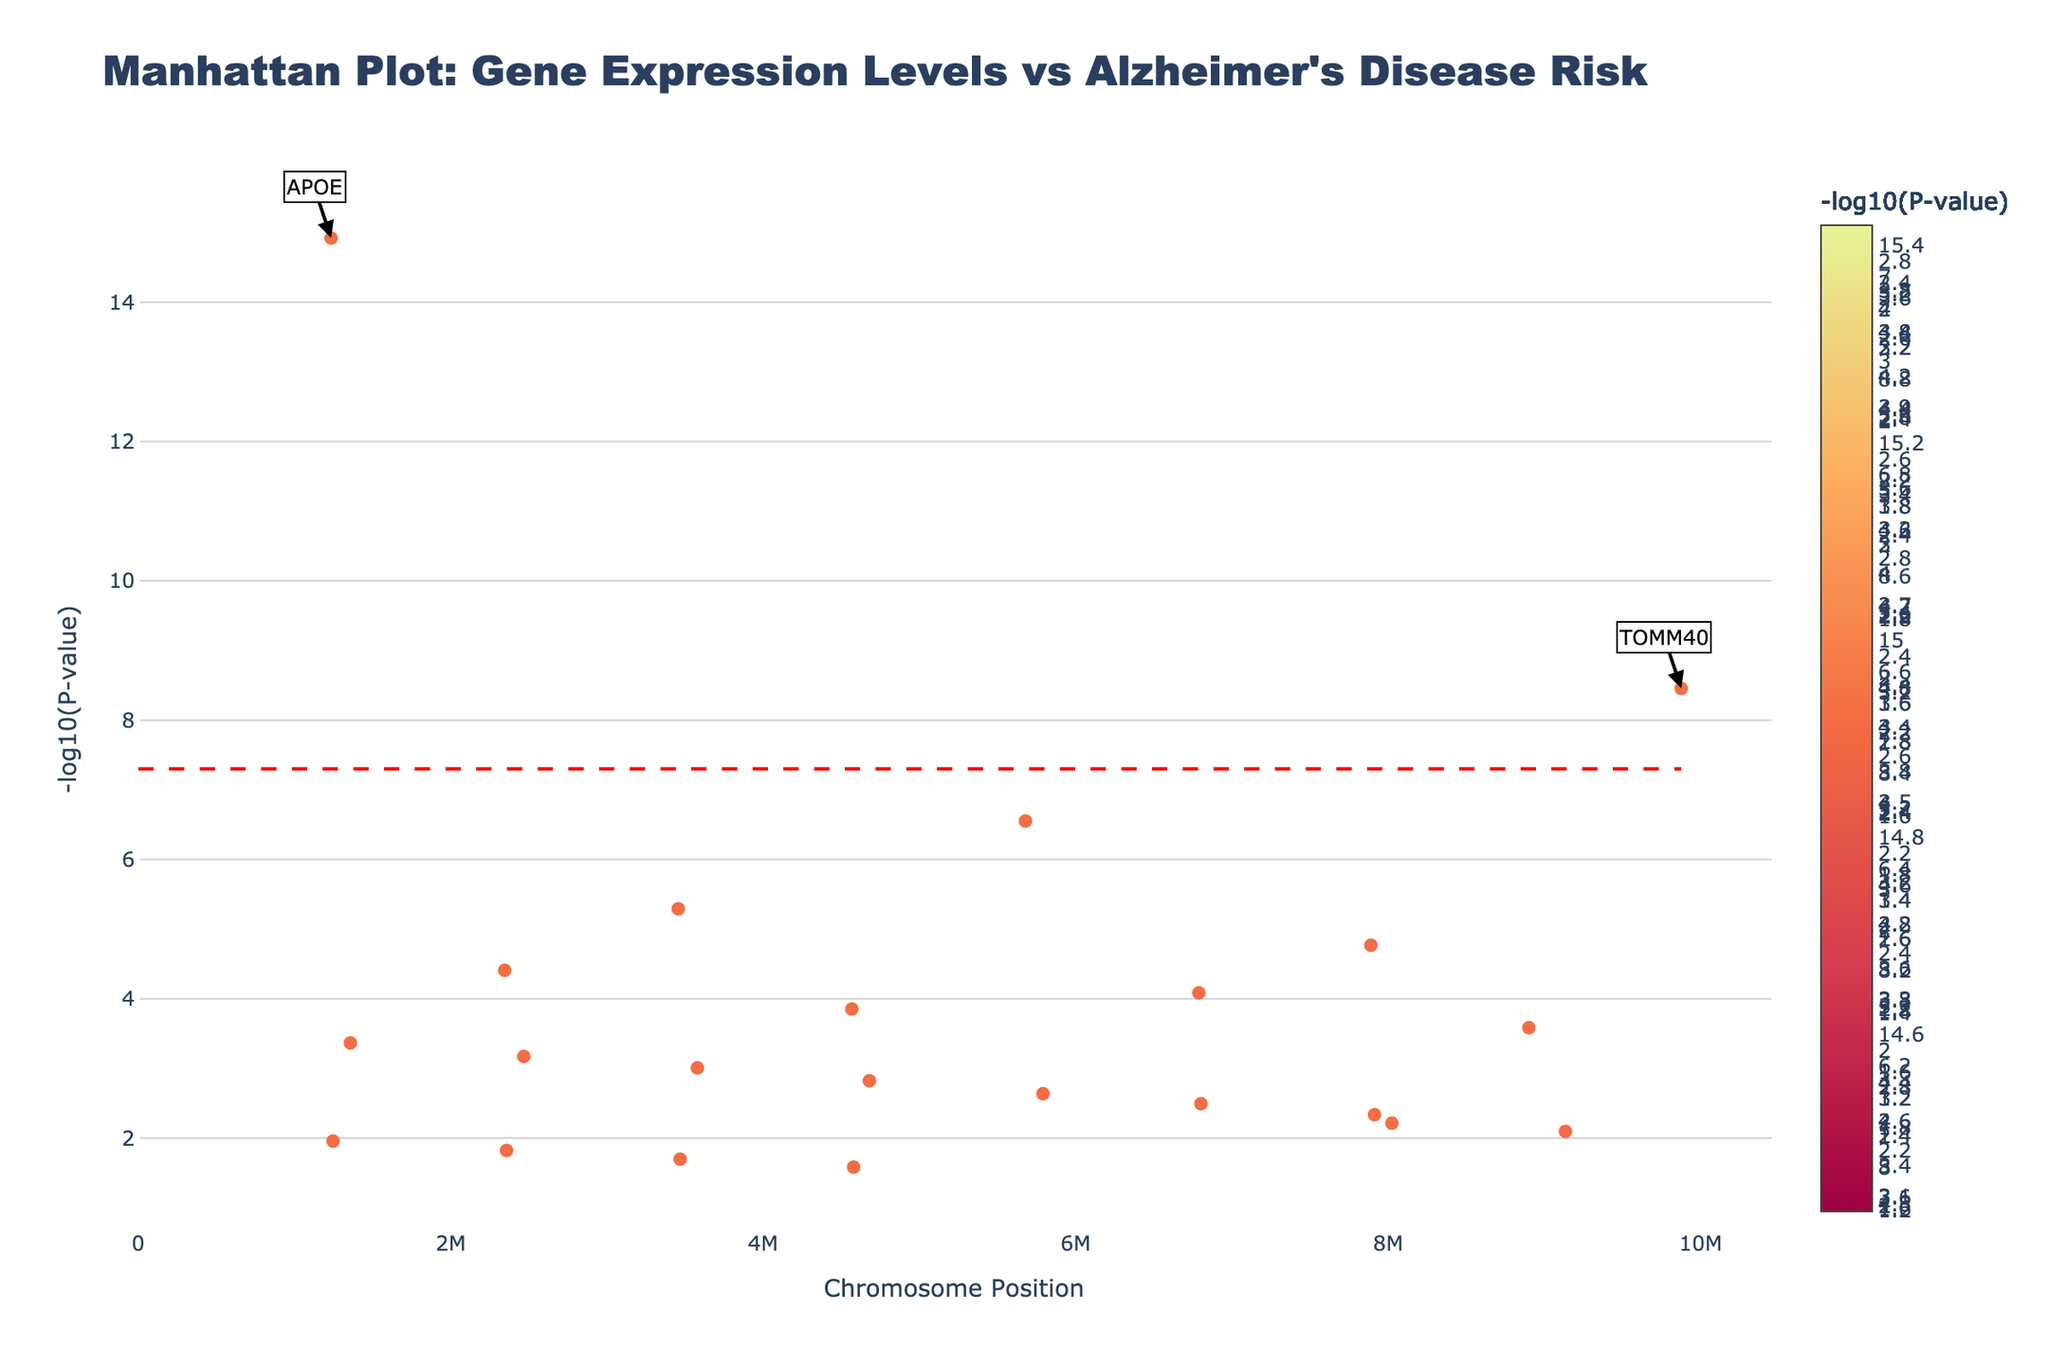What is the title of the plot? The title of the plot is usually displayed at the top of the figure. By locating the title at the top, we can read that it says "Manhattan Plot: Gene Expression Levels vs Alzheimer's Disease Risk."
Answer: Manhattan Plot: Gene Expression Levels vs Alzheimer's Disease Risk What is the y-axis representing? The y-axis in the Manhattan Plot represents the -log10 of the P-value. This is a common transformation used to visualize the significance of associations in genomic studies.
Answer: -log10(P-value) How is statistical significance indicated in the plot? The plot includes a horizontal red dashed line. This line represents the threshold for statistical significance at -log10(5e-8). Any points above this line are considered statistically significant.
Answer: A red dashed line at -log10(5e-8) Which gene has the smallest P-value? By examining the plot, we can identify that the gene labeled highest above on the y-axis (indicating the -log10(P-value)) is APOE. This means APOE has the smallest P-value.
Answer: APOE What is the position of the most significant gene on chromosome 1? The plot shows that APOE is the most significant gene on chromosome 1. Based on the data, its position is 1234567.
Answer: 1234567 How many chromosomes are represented in the plot? By counting the unique groups of points aligned along the x-axis, each group representing a chromosome, we see that there are 22 chromosomes represented in the plot.
Answer: 22 Compare the significance levels of TOMM40 and CLU: Which one is more significant? The y-axis of the plot (-log10(P-value)) allows us to compare the significance. The point for TOMM40 is higher on the y-axis than that of CLU. Thus, TOMM40 has a smaller P-value and is more significant.
Answer: TOMM40 Which gene on chromosome 22 has been analyzed, and what's its P-value? The plot shows annotations for significant genes. On chromosome 22, the gene analyzed is HLA-DRB5 with the corresponding P-value of 2.6e-02.
Answer: HLA-DRB5, 2.6e-02 Are there any chromosomes without statistically significant genes? To determine this, we look at the presence of labeled genes above the significance line. Since only chromosome 1 has labeled points above the red dashed line, all other chromosomes (2 to 22) do not have statistically significant genes.
Answer: Chromosomes 2 to 22 do not have statistically significant genes What is the range of -log10(P-value) for the data points in the plot? To find the range, we look at the highest and lowest data points on the y-axis. The highest value corresponds to APOE, and the lowest corresponds to HLA-DRB5. Based on these, the range is approximately from -log10(1.2e-15) to -log10(2.6e-02).
Answer: From approximately 14.92 to 1.58 